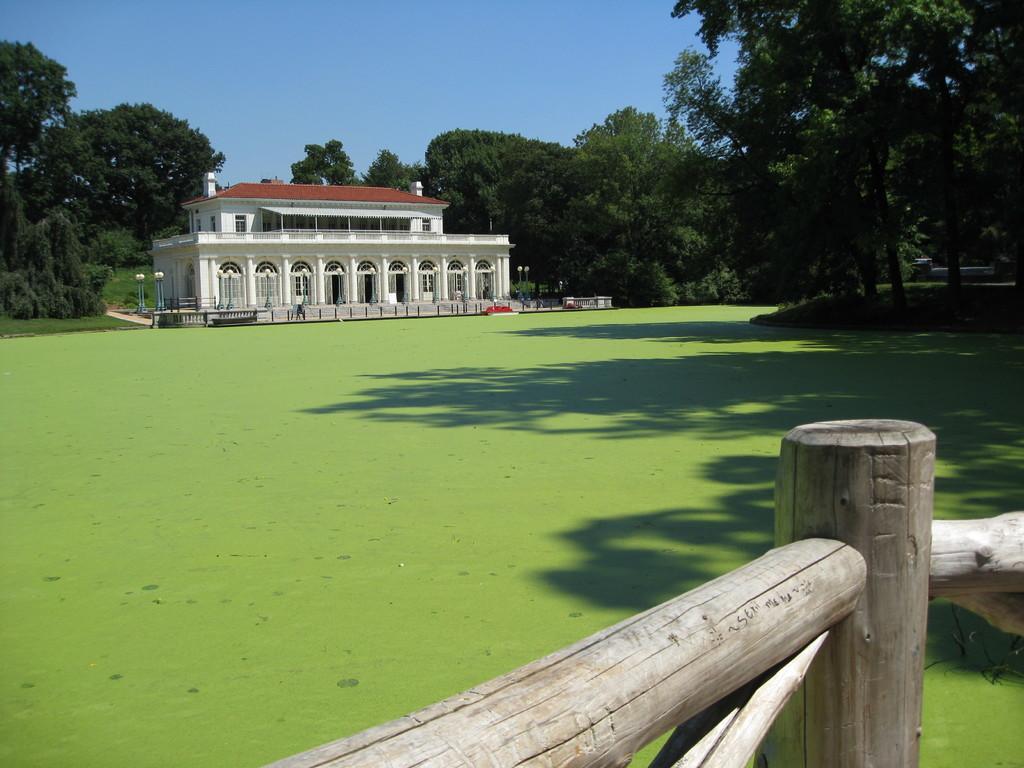Can you describe this image briefly? In the picture we can see a grass surface and railing and far away from it, we can see a house with many doors to it and around the house we can see the poles with lights to it and behind the house we can see full of trees and sky. 